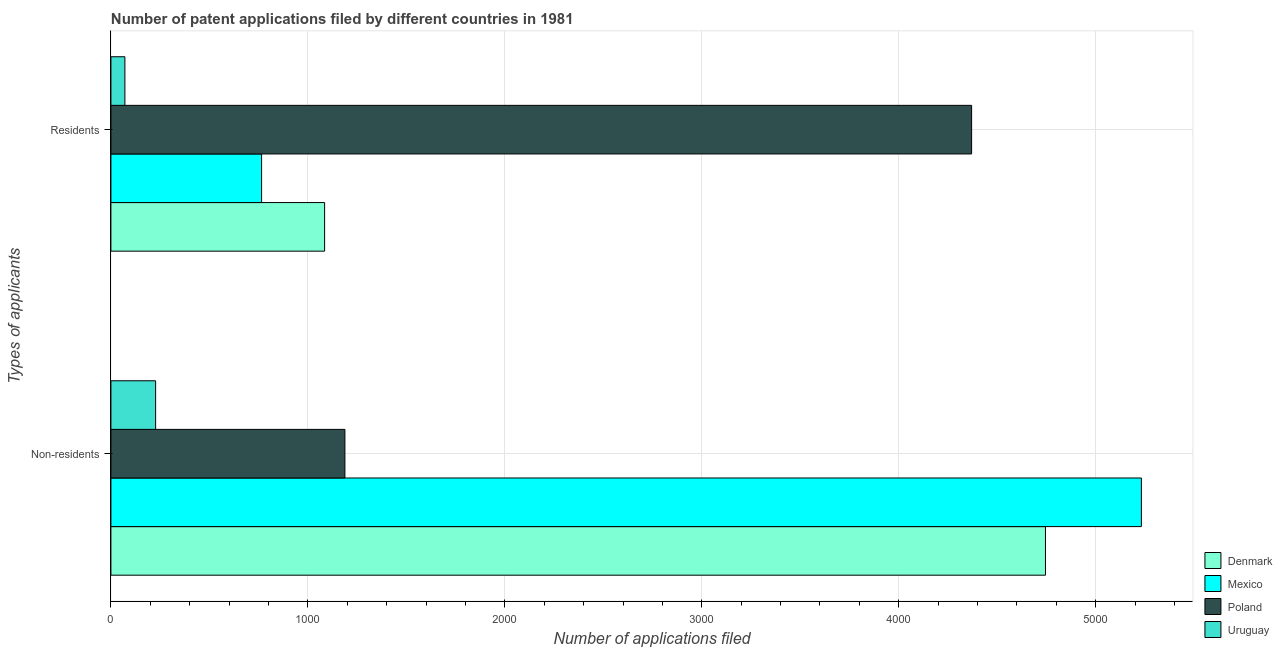How many different coloured bars are there?
Give a very brief answer. 4. How many groups of bars are there?
Offer a terse response. 2. Are the number of bars per tick equal to the number of legend labels?
Offer a very short reply. Yes. Are the number of bars on each tick of the Y-axis equal?
Your answer should be compact. Yes. How many bars are there on the 1st tick from the top?
Keep it short and to the point. 4. What is the label of the 1st group of bars from the top?
Your answer should be compact. Residents. What is the number of patent applications by residents in Uruguay?
Your answer should be very brief. 71. Across all countries, what is the maximum number of patent applications by non residents?
Offer a terse response. 5232. Across all countries, what is the minimum number of patent applications by non residents?
Your response must be concise. 227. In which country was the number of patent applications by non residents maximum?
Ensure brevity in your answer.  Mexico. In which country was the number of patent applications by residents minimum?
Keep it short and to the point. Uruguay. What is the total number of patent applications by residents in the graph?
Keep it short and to the point. 6291. What is the difference between the number of patent applications by residents in Mexico and that in Poland?
Offer a terse response. -3605. What is the difference between the number of patent applications by residents in Poland and the number of patent applications by non residents in Denmark?
Your response must be concise. -375. What is the average number of patent applications by non residents per country?
Keep it short and to the point. 2848. What is the difference between the number of patent applications by residents and number of patent applications by non residents in Denmark?
Your answer should be compact. -3660. In how many countries, is the number of patent applications by non residents greater than 5200 ?
Keep it short and to the point. 1. What is the ratio of the number of patent applications by residents in Mexico to that in Denmark?
Your answer should be very brief. 0.71. Is the number of patent applications by residents in Denmark less than that in Poland?
Offer a terse response. Yes. In how many countries, is the number of patent applications by non residents greater than the average number of patent applications by non residents taken over all countries?
Offer a very short reply. 2. How many bars are there?
Offer a very short reply. 8. Does the graph contain any zero values?
Offer a terse response. No. Where does the legend appear in the graph?
Give a very brief answer. Bottom right. How many legend labels are there?
Offer a terse response. 4. What is the title of the graph?
Provide a succinct answer. Number of patent applications filed by different countries in 1981. Does "Papua New Guinea" appear as one of the legend labels in the graph?
Your answer should be compact. No. What is the label or title of the X-axis?
Your response must be concise. Number of applications filed. What is the label or title of the Y-axis?
Offer a very short reply. Types of applicants. What is the Number of applications filed in Denmark in Non-residents?
Your response must be concise. 4745. What is the Number of applications filed in Mexico in Non-residents?
Keep it short and to the point. 5232. What is the Number of applications filed in Poland in Non-residents?
Your answer should be very brief. 1188. What is the Number of applications filed in Uruguay in Non-residents?
Your answer should be compact. 227. What is the Number of applications filed of Denmark in Residents?
Provide a short and direct response. 1085. What is the Number of applications filed in Mexico in Residents?
Your response must be concise. 765. What is the Number of applications filed in Poland in Residents?
Make the answer very short. 4370. What is the Number of applications filed in Uruguay in Residents?
Keep it short and to the point. 71. Across all Types of applicants, what is the maximum Number of applications filed in Denmark?
Keep it short and to the point. 4745. Across all Types of applicants, what is the maximum Number of applications filed in Mexico?
Ensure brevity in your answer.  5232. Across all Types of applicants, what is the maximum Number of applications filed of Poland?
Provide a short and direct response. 4370. Across all Types of applicants, what is the maximum Number of applications filed of Uruguay?
Offer a very short reply. 227. Across all Types of applicants, what is the minimum Number of applications filed in Denmark?
Your answer should be very brief. 1085. Across all Types of applicants, what is the minimum Number of applications filed in Mexico?
Ensure brevity in your answer.  765. Across all Types of applicants, what is the minimum Number of applications filed of Poland?
Keep it short and to the point. 1188. What is the total Number of applications filed of Denmark in the graph?
Keep it short and to the point. 5830. What is the total Number of applications filed of Mexico in the graph?
Keep it short and to the point. 5997. What is the total Number of applications filed in Poland in the graph?
Offer a terse response. 5558. What is the total Number of applications filed of Uruguay in the graph?
Give a very brief answer. 298. What is the difference between the Number of applications filed in Denmark in Non-residents and that in Residents?
Provide a succinct answer. 3660. What is the difference between the Number of applications filed in Mexico in Non-residents and that in Residents?
Ensure brevity in your answer.  4467. What is the difference between the Number of applications filed in Poland in Non-residents and that in Residents?
Offer a terse response. -3182. What is the difference between the Number of applications filed in Uruguay in Non-residents and that in Residents?
Provide a short and direct response. 156. What is the difference between the Number of applications filed of Denmark in Non-residents and the Number of applications filed of Mexico in Residents?
Ensure brevity in your answer.  3980. What is the difference between the Number of applications filed in Denmark in Non-residents and the Number of applications filed in Poland in Residents?
Offer a very short reply. 375. What is the difference between the Number of applications filed of Denmark in Non-residents and the Number of applications filed of Uruguay in Residents?
Keep it short and to the point. 4674. What is the difference between the Number of applications filed in Mexico in Non-residents and the Number of applications filed in Poland in Residents?
Provide a succinct answer. 862. What is the difference between the Number of applications filed of Mexico in Non-residents and the Number of applications filed of Uruguay in Residents?
Give a very brief answer. 5161. What is the difference between the Number of applications filed in Poland in Non-residents and the Number of applications filed in Uruguay in Residents?
Make the answer very short. 1117. What is the average Number of applications filed of Denmark per Types of applicants?
Your answer should be compact. 2915. What is the average Number of applications filed in Mexico per Types of applicants?
Give a very brief answer. 2998.5. What is the average Number of applications filed in Poland per Types of applicants?
Your answer should be very brief. 2779. What is the average Number of applications filed of Uruguay per Types of applicants?
Your answer should be compact. 149. What is the difference between the Number of applications filed of Denmark and Number of applications filed of Mexico in Non-residents?
Make the answer very short. -487. What is the difference between the Number of applications filed in Denmark and Number of applications filed in Poland in Non-residents?
Provide a succinct answer. 3557. What is the difference between the Number of applications filed of Denmark and Number of applications filed of Uruguay in Non-residents?
Your response must be concise. 4518. What is the difference between the Number of applications filed in Mexico and Number of applications filed in Poland in Non-residents?
Provide a short and direct response. 4044. What is the difference between the Number of applications filed of Mexico and Number of applications filed of Uruguay in Non-residents?
Offer a terse response. 5005. What is the difference between the Number of applications filed in Poland and Number of applications filed in Uruguay in Non-residents?
Keep it short and to the point. 961. What is the difference between the Number of applications filed of Denmark and Number of applications filed of Mexico in Residents?
Provide a succinct answer. 320. What is the difference between the Number of applications filed in Denmark and Number of applications filed in Poland in Residents?
Offer a very short reply. -3285. What is the difference between the Number of applications filed of Denmark and Number of applications filed of Uruguay in Residents?
Offer a very short reply. 1014. What is the difference between the Number of applications filed of Mexico and Number of applications filed of Poland in Residents?
Your answer should be very brief. -3605. What is the difference between the Number of applications filed of Mexico and Number of applications filed of Uruguay in Residents?
Give a very brief answer. 694. What is the difference between the Number of applications filed in Poland and Number of applications filed in Uruguay in Residents?
Provide a succinct answer. 4299. What is the ratio of the Number of applications filed of Denmark in Non-residents to that in Residents?
Ensure brevity in your answer.  4.37. What is the ratio of the Number of applications filed of Mexico in Non-residents to that in Residents?
Offer a terse response. 6.84. What is the ratio of the Number of applications filed in Poland in Non-residents to that in Residents?
Your response must be concise. 0.27. What is the ratio of the Number of applications filed in Uruguay in Non-residents to that in Residents?
Offer a very short reply. 3.2. What is the difference between the highest and the second highest Number of applications filed of Denmark?
Keep it short and to the point. 3660. What is the difference between the highest and the second highest Number of applications filed of Mexico?
Offer a very short reply. 4467. What is the difference between the highest and the second highest Number of applications filed in Poland?
Ensure brevity in your answer.  3182. What is the difference between the highest and the second highest Number of applications filed in Uruguay?
Your answer should be very brief. 156. What is the difference between the highest and the lowest Number of applications filed of Denmark?
Make the answer very short. 3660. What is the difference between the highest and the lowest Number of applications filed in Mexico?
Offer a very short reply. 4467. What is the difference between the highest and the lowest Number of applications filed in Poland?
Ensure brevity in your answer.  3182. What is the difference between the highest and the lowest Number of applications filed in Uruguay?
Your answer should be compact. 156. 